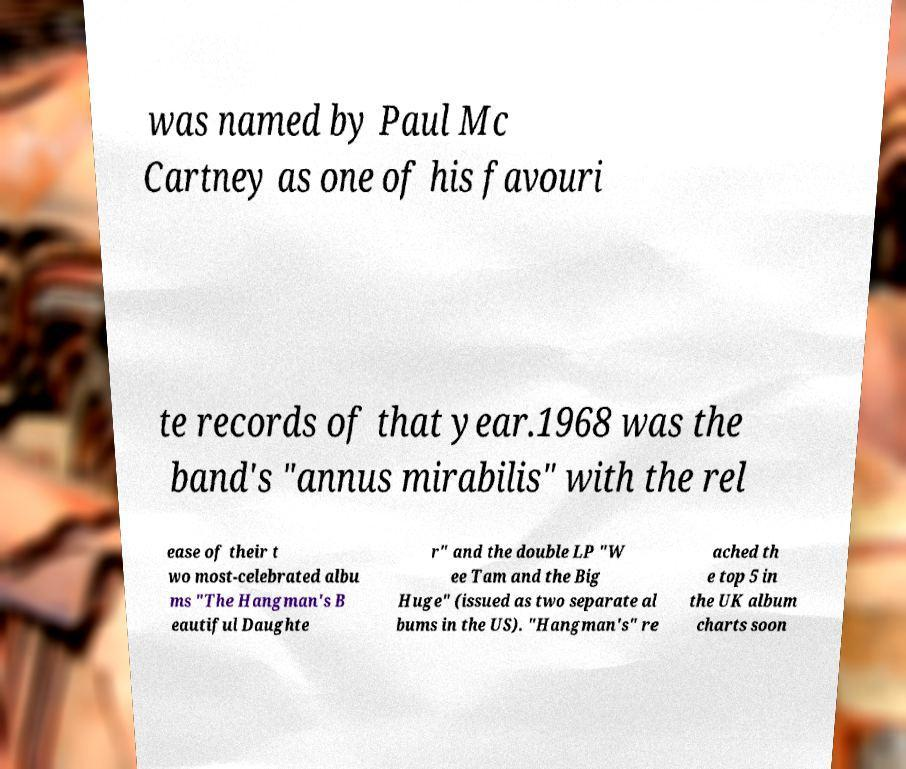Could you assist in decoding the text presented in this image and type it out clearly? was named by Paul Mc Cartney as one of his favouri te records of that year.1968 was the band's "annus mirabilis" with the rel ease of their t wo most-celebrated albu ms "The Hangman's B eautiful Daughte r" and the double LP "W ee Tam and the Big Huge" (issued as two separate al bums in the US). "Hangman's" re ached th e top 5 in the UK album charts soon 